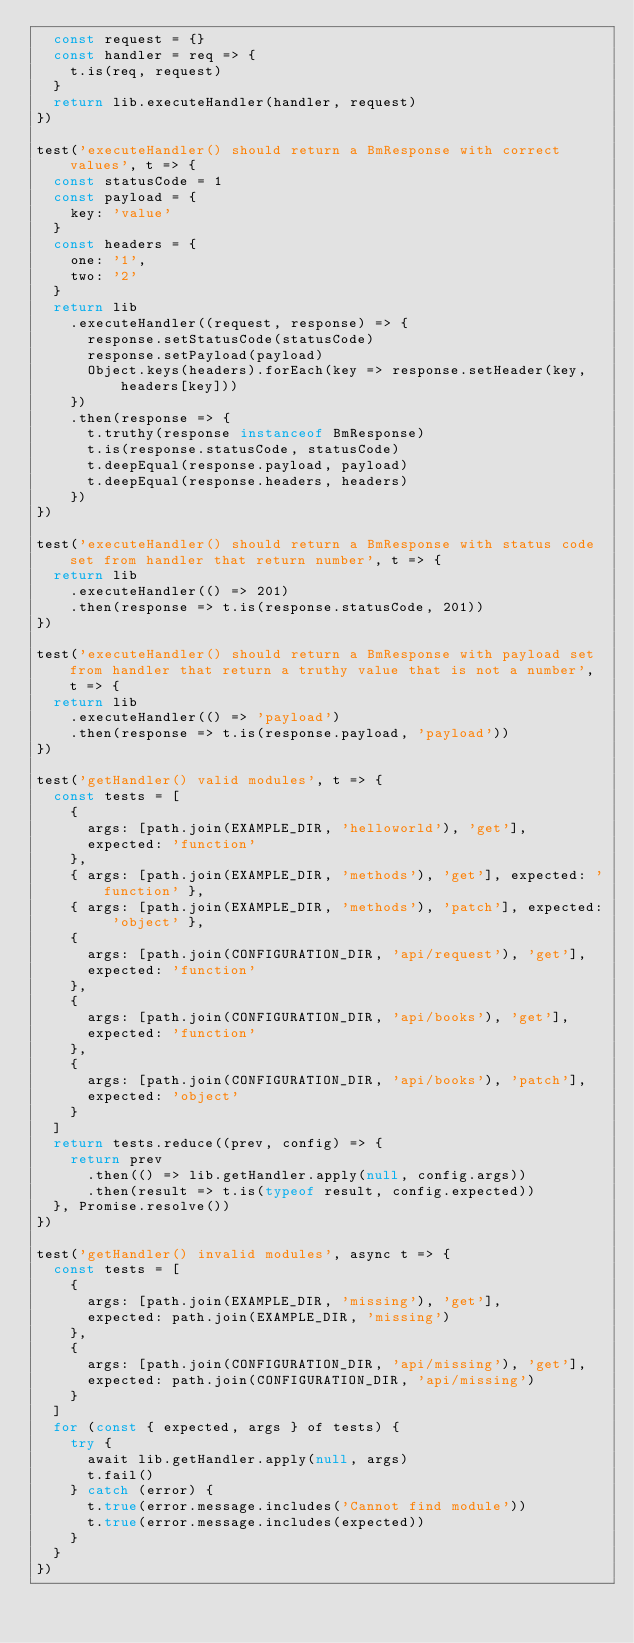<code> <loc_0><loc_0><loc_500><loc_500><_JavaScript_>  const request = {}
  const handler = req => {
    t.is(req, request)
  }
  return lib.executeHandler(handler, request)
})

test('executeHandler() should return a BmResponse with correct values', t => {
  const statusCode = 1
  const payload = {
    key: 'value'
  }
  const headers = {
    one: '1',
    two: '2'
  }
  return lib
    .executeHandler((request, response) => {
      response.setStatusCode(statusCode)
      response.setPayload(payload)
      Object.keys(headers).forEach(key => response.setHeader(key, headers[key]))
    })
    .then(response => {
      t.truthy(response instanceof BmResponse)
      t.is(response.statusCode, statusCode)
      t.deepEqual(response.payload, payload)
      t.deepEqual(response.headers, headers)
    })
})

test('executeHandler() should return a BmResponse with status code set from handler that return number', t => {
  return lib
    .executeHandler(() => 201)
    .then(response => t.is(response.statusCode, 201))
})

test('executeHandler() should return a BmResponse with payload set from handler that return a truthy value that is not a number', t => {
  return lib
    .executeHandler(() => 'payload')
    .then(response => t.is(response.payload, 'payload'))
})

test('getHandler() valid modules', t => {
  const tests = [
    {
      args: [path.join(EXAMPLE_DIR, 'helloworld'), 'get'],
      expected: 'function'
    },
    { args: [path.join(EXAMPLE_DIR, 'methods'), 'get'], expected: 'function' },
    { args: [path.join(EXAMPLE_DIR, 'methods'), 'patch'], expected: 'object' },
    {
      args: [path.join(CONFIGURATION_DIR, 'api/request'), 'get'],
      expected: 'function'
    },
    {
      args: [path.join(CONFIGURATION_DIR, 'api/books'), 'get'],
      expected: 'function'
    },
    {
      args: [path.join(CONFIGURATION_DIR, 'api/books'), 'patch'],
      expected: 'object'
    }
  ]
  return tests.reduce((prev, config) => {
    return prev
      .then(() => lib.getHandler.apply(null, config.args))
      .then(result => t.is(typeof result, config.expected))
  }, Promise.resolve())
})

test('getHandler() invalid modules', async t => {
  const tests = [
    {
      args: [path.join(EXAMPLE_DIR, 'missing'), 'get'],
      expected: path.join(EXAMPLE_DIR, 'missing')
    },
    {
      args: [path.join(CONFIGURATION_DIR, 'api/missing'), 'get'],
      expected: path.join(CONFIGURATION_DIR, 'api/missing')
    }
  ]
  for (const { expected, args } of tests) {
    try {
      await lib.getHandler.apply(null, args)
      t.fail()
    } catch (error) {
      t.true(error.message.includes('Cannot find module'))
      t.true(error.message.includes(expected))
    }
  }
})
</code> 